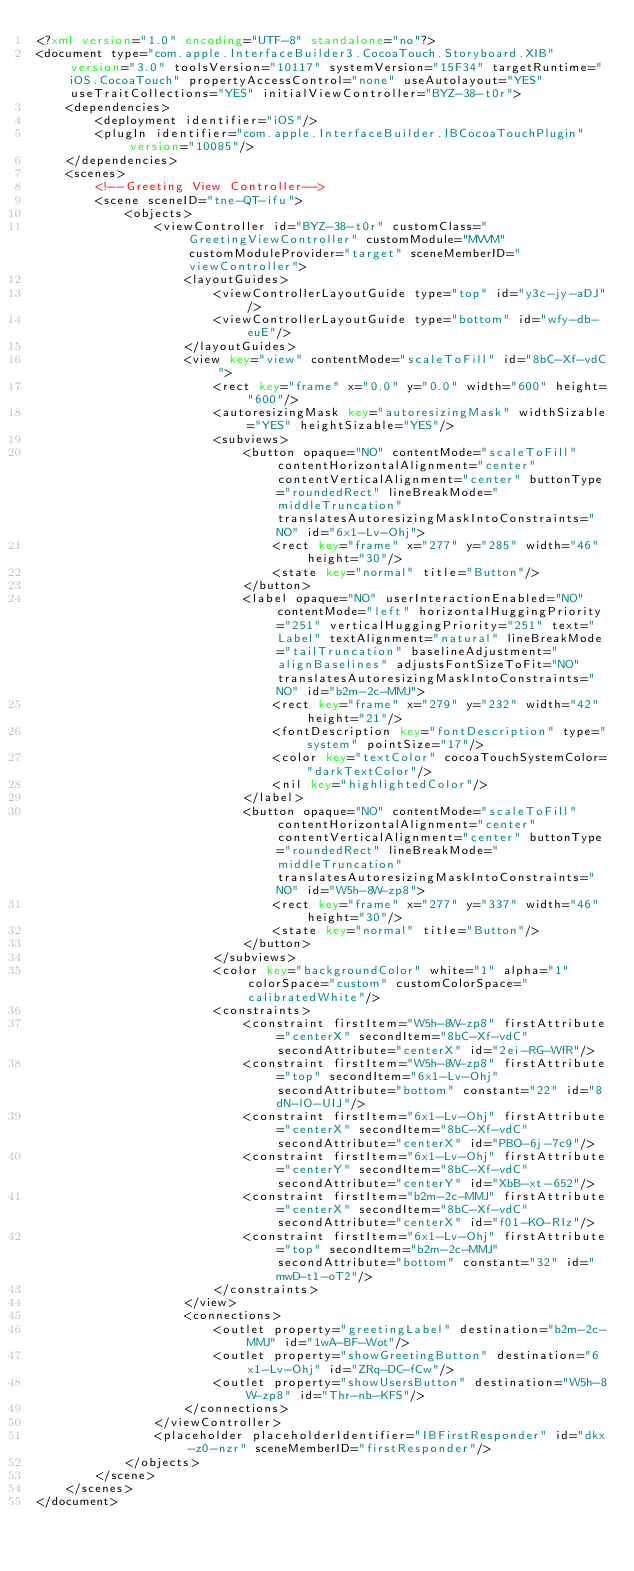<code> <loc_0><loc_0><loc_500><loc_500><_XML_><?xml version="1.0" encoding="UTF-8" standalone="no"?>
<document type="com.apple.InterfaceBuilder3.CocoaTouch.Storyboard.XIB" version="3.0" toolsVersion="10117" systemVersion="15F34" targetRuntime="iOS.CocoaTouch" propertyAccessControl="none" useAutolayout="YES" useTraitCollections="YES" initialViewController="BYZ-38-t0r">
    <dependencies>
        <deployment identifier="iOS"/>
        <plugIn identifier="com.apple.InterfaceBuilder.IBCocoaTouchPlugin" version="10085"/>
    </dependencies>
    <scenes>
        <!--Greeting View Controller-->
        <scene sceneID="tne-QT-ifu">
            <objects>
                <viewController id="BYZ-38-t0r" customClass="GreetingViewController" customModule="MVVM" customModuleProvider="target" sceneMemberID="viewController">
                    <layoutGuides>
                        <viewControllerLayoutGuide type="top" id="y3c-jy-aDJ"/>
                        <viewControllerLayoutGuide type="bottom" id="wfy-db-euE"/>
                    </layoutGuides>
                    <view key="view" contentMode="scaleToFill" id="8bC-Xf-vdC">
                        <rect key="frame" x="0.0" y="0.0" width="600" height="600"/>
                        <autoresizingMask key="autoresizingMask" widthSizable="YES" heightSizable="YES"/>
                        <subviews>
                            <button opaque="NO" contentMode="scaleToFill" contentHorizontalAlignment="center" contentVerticalAlignment="center" buttonType="roundedRect" lineBreakMode="middleTruncation" translatesAutoresizingMaskIntoConstraints="NO" id="6x1-Lv-Ohj">
                                <rect key="frame" x="277" y="285" width="46" height="30"/>
                                <state key="normal" title="Button"/>
                            </button>
                            <label opaque="NO" userInteractionEnabled="NO" contentMode="left" horizontalHuggingPriority="251" verticalHuggingPriority="251" text="Label" textAlignment="natural" lineBreakMode="tailTruncation" baselineAdjustment="alignBaselines" adjustsFontSizeToFit="NO" translatesAutoresizingMaskIntoConstraints="NO" id="b2m-2c-MMJ">
                                <rect key="frame" x="279" y="232" width="42" height="21"/>
                                <fontDescription key="fontDescription" type="system" pointSize="17"/>
                                <color key="textColor" cocoaTouchSystemColor="darkTextColor"/>
                                <nil key="highlightedColor"/>
                            </label>
                            <button opaque="NO" contentMode="scaleToFill" contentHorizontalAlignment="center" contentVerticalAlignment="center" buttonType="roundedRect" lineBreakMode="middleTruncation" translatesAutoresizingMaskIntoConstraints="NO" id="W5h-8W-zp8">
                                <rect key="frame" x="277" y="337" width="46" height="30"/>
                                <state key="normal" title="Button"/>
                            </button>
                        </subviews>
                        <color key="backgroundColor" white="1" alpha="1" colorSpace="custom" customColorSpace="calibratedWhite"/>
                        <constraints>
                            <constraint firstItem="W5h-8W-zp8" firstAttribute="centerX" secondItem="8bC-Xf-vdC" secondAttribute="centerX" id="2ei-RG-WfR"/>
                            <constraint firstItem="W5h-8W-zp8" firstAttribute="top" secondItem="6x1-Lv-Ohj" secondAttribute="bottom" constant="22" id="8dN-lO-UIJ"/>
                            <constraint firstItem="6x1-Lv-Ohj" firstAttribute="centerX" secondItem="8bC-Xf-vdC" secondAttribute="centerX" id="PBO-6j-7c9"/>
                            <constraint firstItem="6x1-Lv-Ohj" firstAttribute="centerY" secondItem="8bC-Xf-vdC" secondAttribute="centerY" id="XbB-xt-652"/>
                            <constraint firstItem="b2m-2c-MMJ" firstAttribute="centerX" secondItem="8bC-Xf-vdC" secondAttribute="centerX" id="f01-KO-RIz"/>
                            <constraint firstItem="6x1-Lv-Ohj" firstAttribute="top" secondItem="b2m-2c-MMJ" secondAttribute="bottom" constant="32" id="mwD-t1-oT2"/>
                        </constraints>
                    </view>
                    <connections>
                        <outlet property="greetingLabel" destination="b2m-2c-MMJ" id="1wA-BF-Wot"/>
                        <outlet property="showGreetingButton" destination="6x1-Lv-Ohj" id="ZRq-DC-fCw"/>
                        <outlet property="showUsersButton" destination="W5h-8W-zp8" id="Thr-nb-KFS"/>
                    </connections>
                </viewController>
                <placeholder placeholderIdentifier="IBFirstResponder" id="dkx-z0-nzr" sceneMemberID="firstResponder"/>
            </objects>
        </scene>
    </scenes>
</document>
</code> 